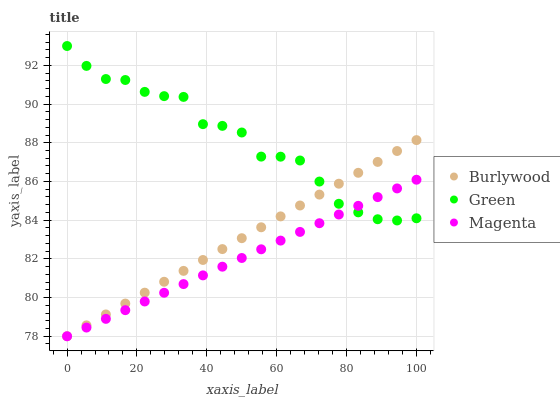Does Magenta have the minimum area under the curve?
Answer yes or no. Yes. Does Green have the maximum area under the curve?
Answer yes or no. Yes. Does Green have the minimum area under the curve?
Answer yes or no. No. Does Magenta have the maximum area under the curve?
Answer yes or no. No. Is Burlywood the smoothest?
Answer yes or no. Yes. Is Green the roughest?
Answer yes or no. Yes. Is Magenta the smoothest?
Answer yes or no. No. Is Magenta the roughest?
Answer yes or no. No. Does Burlywood have the lowest value?
Answer yes or no. Yes. Does Green have the lowest value?
Answer yes or no. No. Does Green have the highest value?
Answer yes or no. Yes. Does Magenta have the highest value?
Answer yes or no. No. Does Magenta intersect Burlywood?
Answer yes or no. Yes. Is Magenta less than Burlywood?
Answer yes or no. No. Is Magenta greater than Burlywood?
Answer yes or no. No. 